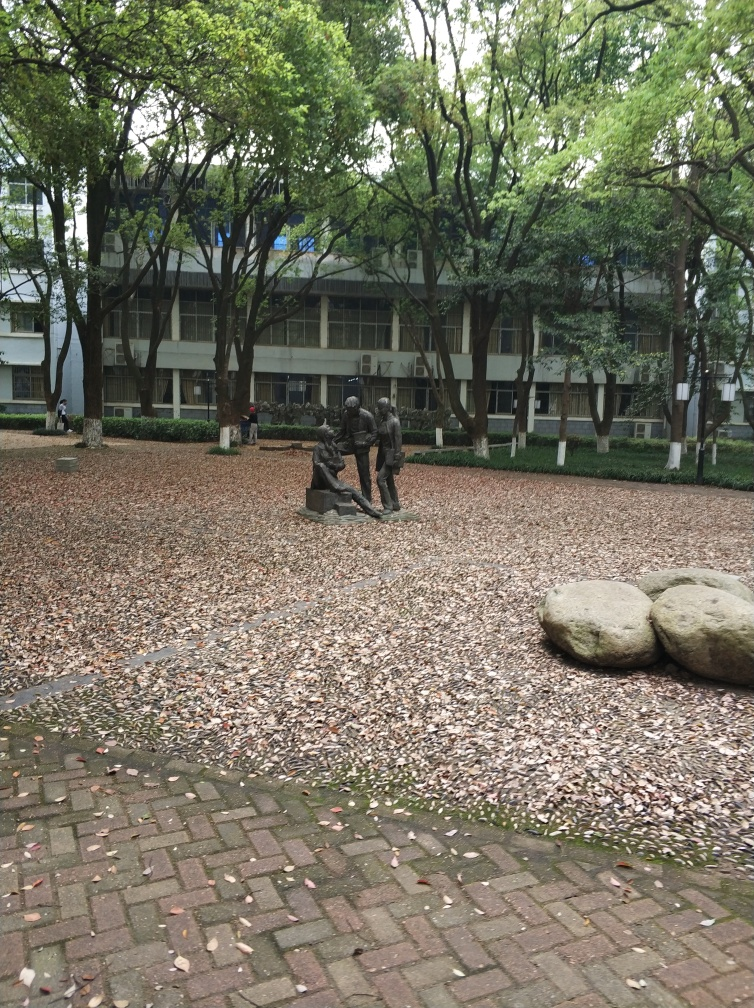How are the texture details of the ground? The ground displays a natural mosaic created by a layer of fallen leaves, which vary in color from brown to reddish hues, interspersed on a bed of muted red and grayish bricks. The leaves appear to be mostly dry, indicating a season of autumn, and they contribute to a textured, organic carpet that softens the otherwise hard brick surface. 